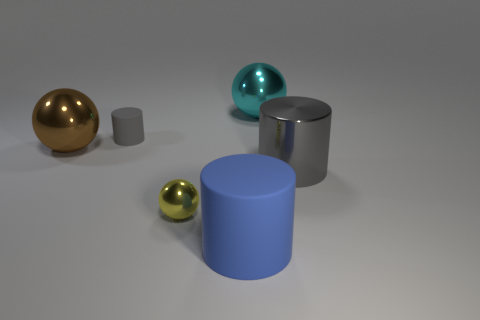There is a metallic object behind the brown metallic object; is it the same shape as the yellow object?
Make the answer very short. Yes. What shape is the large shiny object that is left of the large blue cylinder?
Your answer should be compact. Sphere. Are there any brown things that have the same material as the large cyan ball?
Your answer should be compact. Yes. Does the large shiny object that is left of the big rubber object have the same color as the tiny matte object?
Provide a succinct answer. No. How big is the cyan metal ball?
Give a very brief answer. Large. There is a large object right of the metallic ball behind the tiny gray rubber object; are there any blue things right of it?
Your answer should be very brief. No. What number of tiny yellow shiny things are on the right side of the cyan shiny sphere?
Your answer should be compact. 0. What number of big cylinders are the same color as the small cylinder?
Give a very brief answer. 1. What number of things are metal balls behind the shiny cylinder or large shiny things that are on the left side of the large gray cylinder?
Your answer should be very brief. 2. Is the number of brown matte blocks greater than the number of tiny metal spheres?
Offer a very short reply. No. 